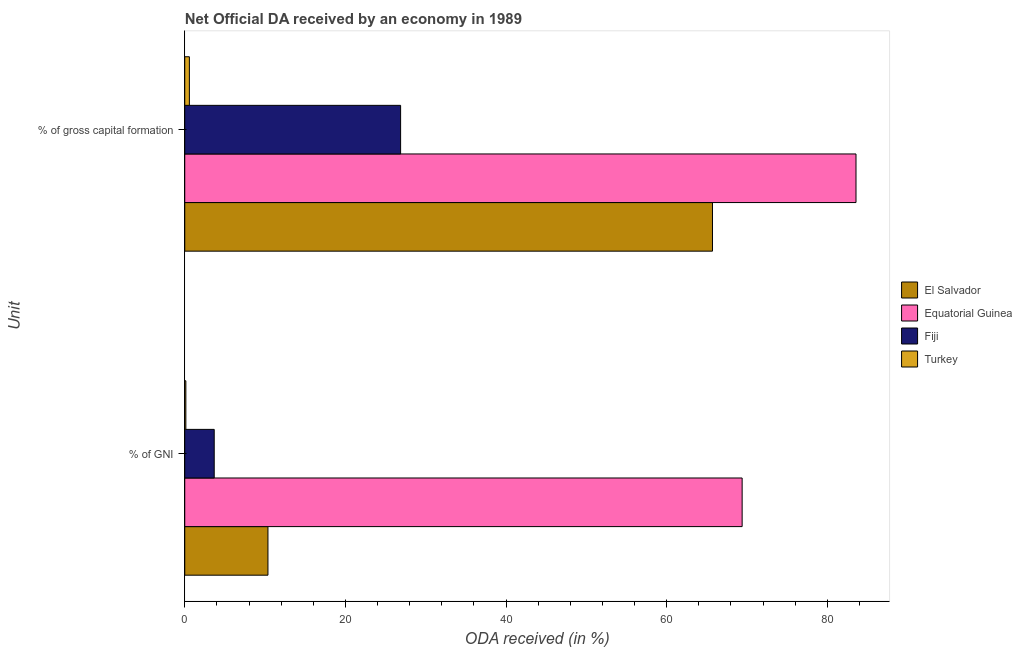Are the number of bars per tick equal to the number of legend labels?
Provide a short and direct response. Yes. What is the label of the 2nd group of bars from the top?
Give a very brief answer. % of GNI. What is the oda received as percentage of gross capital formation in El Salvador?
Keep it short and to the point. 65.71. Across all countries, what is the maximum oda received as percentage of gross capital formation?
Provide a short and direct response. 83.58. Across all countries, what is the minimum oda received as percentage of gross capital formation?
Your answer should be compact. 0.58. In which country was the oda received as percentage of gross capital formation maximum?
Your answer should be very brief. Equatorial Guinea. What is the total oda received as percentage of gni in the graph?
Your response must be concise. 83.57. What is the difference between the oda received as percentage of gross capital formation in Fiji and that in Equatorial Guinea?
Ensure brevity in your answer.  -56.7. What is the difference between the oda received as percentage of gni in Turkey and the oda received as percentage of gross capital formation in Fiji?
Make the answer very short. -26.74. What is the average oda received as percentage of gross capital formation per country?
Your response must be concise. 44.19. What is the difference between the oda received as percentage of gni and oda received as percentage of gross capital formation in Fiji?
Offer a very short reply. -23.21. In how many countries, is the oda received as percentage of gross capital formation greater than 44 %?
Your answer should be compact. 2. What is the ratio of the oda received as percentage of gross capital formation in Fiji to that in Turkey?
Provide a short and direct response. 46.65. Is the oda received as percentage of gross capital formation in Fiji less than that in El Salvador?
Your answer should be compact. Yes. What does the 2nd bar from the top in % of gross capital formation represents?
Ensure brevity in your answer.  Fiji. Are the values on the major ticks of X-axis written in scientific E-notation?
Your answer should be compact. No. Does the graph contain any zero values?
Ensure brevity in your answer.  No. Does the graph contain grids?
Your response must be concise. No. What is the title of the graph?
Ensure brevity in your answer.  Net Official DA received by an economy in 1989. What is the label or title of the X-axis?
Offer a terse response. ODA received (in %). What is the label or title of the Y-axis?
Give a very brief answer. Unit. What is the ODA received (in %) of El Salvador in % of GNI?
Your answer should be very brief. 10.36. What is the ODA received (in %) of Equatorial Guinea in % of GNI?
Make the answer very short. 69.4. What is the ODA received (in %) of Fiji in % of GNI?
Offer a terse response. 3.67. What is the ODA received (in %) of Turkey in % of GNI?
Make the answer very short. 0.14. What is the ODA received (in %) in El Salvador in % of gross capital formation?
Ensure brevity in your answer.  65.71. What is the ODA received (in %) in Equatorial Guinea in % of gross capital formation?
Give a very brief answer. 83.58. What is the ODA received (in %) of Fiji in % of gross capital formation?
Make the answer very short. 26.88. What is the ODA received (in %) of Turkey in % of gross capital formation?
Offer a terse response. 0.58. Across all Unit, what is the maximum ODA received (in %) in El Salvador?
Your response must be concise. 65.71. Across all Unit, what is the maximum ODA received (in %) of Equatorial Guinea?
Keep it short and to the point. 83.58. Across all Unit, what is the maximum ODA received (in %) of Fiji?
Provide a short and direct response. 26.88. Across all Unit, what is the maximum ODA received (in %) in Turkey?
Your answer should be very brief. 0.58. Across all Unit, what is the minimum ODA received (in %) of El Salvador?
Your answer should be very brief. 10.36. Across all Unit, what is the minimum ODA received (in %) of Equatorial Guinea?
Ensure brevity in your answer.  69.4. Across all Unit, what is the minimum ODA received (in %) of Fiji?
Make the answer very short. 3.67. Across all Unit, what is the minimum ODA received (in %) of Turkey?
Your response must be concise. 0.14. What is the total ODA received (in %) of El Salvador in the graph?
Make the answer very short. 76.07. What is the total ODA received (in %) of Equatorial Guinea in the graph?
Your answer should be very brief. 152.98. What is the total ODA received (in %) in Fiji in the graph?
Your answer should be very brief. 30.55. What is the total ODA received (in %) of Turkey in the graph?
Your answer should be compact. 0.71. What is the difference between the ODA received (in %) in El Salvador in % of GNI and that in % of gross capital formation?
Your answer should be compact. -55.35. What is the difference between the ODA received (in %) in Equatorial Guinea in % of GNI and that in % of gross capital formation?
Your answer should be compact. -14.18. What is the difference between the ODA received (in %) in Fiji in % of GNI and that in % of gross capital formation?
Provide a short and direct response. -23.21. What is the difference between the ODA received (in %) of Turkey in % of GNI and that in % of gross capital formation?
Keep it short and to the point. -0.44. What is the difference between the ODA received (in %) of El Salvador in % of GNI and the ODA received (in %) of Equatorial Guinea in % of gross capital formation?
Ensure brevity in your answer.  -73.22. What is the difference between the ODA received (in %) of El Salvador in % of GNI and the ODA received (in %) of Fiji in % of gross capital formation?
Make the answer very short. -16.52. What is the difference between the ODA received (in %) in El Salvador in % of GNI and the ODA received (in %) in Turkey in % of gross capital formation?
Give a very brief answer. 9.78. What is the difference between the ODA received (in %) of Equatorial Guinea in % of GNI and the ODA received (in %) of Fiji in % of gross capital formation?
Make the answer very short. 42.52. What is the difference between the ODA received (in %) of Equatorial Guinea in % of GNI and the ODA received (in %) of Turkey in % of gross capital formation?
Offer a terse response. 68.83. What is the difference between the ODA received (in %) of Fiji in % of GNI and the ODA received (in %) of Turkey in % of gross capital formation?
Your answer should be compact. 3.09. What is the average ODA received (in %) in El Salvador per Unit?
Ensure brevity in your answer.  38.03. What is the average ODA received (in %) of Equatorial Guinea per Unit?
Your answer should be very brief. 76.49. What is the average ODA received (in %) in Fiji per Unit?
Offer a terse response. 15.27. What is the average ODA received (in %) of Turkey per Unit?
Make the answer very short. 0.36. What is the difference between the ODA received (in %) in El Salvador and ODA received (in %) in Equatorial Guinea in % of GNI?
Your response must be concise. -59.04. What is the difference between the ODA received (in %) in El Salvador and ODA received (in %) in Fiji in % of GNI?
Your answer should be compact. 6.69. What is the difference between the ODA received (in %) in El Salvador and ODA received (in %) in Turkey in % of GNI?
Offer a very short reply. 10.22. What is the difference between the ODA received (in %) of Equatorial Guinea and ODA received (in %) of Fiji in % of GNI?
Give a very brief answer. 65.73. What is the difference between the ODA received (in %) in Equatorial Guinea and ODA received (in %) in Turkey in % of GNI?
Make the answer very short. 69.26. What is the difference between the ODA received (in %) of Fiji and ODA received (in %) of Turkey in % of GNI?
Make the answer very short. 3.53. What is the difference between the ODA received (in %) in El Salvador and ODA received (in %) in Equatorial Guinea in % of gross capital formation?
Keep it short and to the point. -17.87. What is the difference between the ODA received (in %) in El Salvador and ODA received (in %) in Fiji in % of gross capital formation?
Provide a short and direct response. 38.83. What is the difference between the ODA received (in %) in El Salvador and ODA received (in %) in Turkey in % of gross capital formation?
Your answer should be very brief. 65.13. What is the difference between the ODA received (in %) of Equatorial Guinea and ODA received (in %) of Fiji in % of gross capital formation?
Your answer should be very brief. 56.7. What is the difference between the ODA received (in %) of Equatorial Guinea and ODA received (in %) of Turkey in % of gross capital formation?
Your response must be concise. 83. What is the difference between the ODA received (in %) of Fiji and ODA received (in %) of Turkey in % of gross capital formation?
Ensure brevity in your answer.  26.3. What is the ratio of the ODA received (in %) in El Salvador in % of GNI to that in % of gross capital formation?
Offer a terse response. 0.16. What is the ratio of the ODA received (in %) of Equatorial Guinea in % of GNI to that in % of gross capital formation?
Your answer should be compact. 0.83. What is the ratio of the ODA received (in %) in Fiji in % of GNI to that in % of gross capital formation?
Provide a short and direct response. 0.14. What is the ratio of the ODA received (in %) of Turkey in % of GNI to that in % of gross capital formation?
Ensure brevity in your answer.  0.24. What is the difference between the highest and the second highest ODA received (in %) of El Salvador?
Offer a very short reply. 55.35. What is the difference between the highest and the second highest ODA received (in %) of Equatorial Guinea?
Make the answer very short. 14.18. What is the difference between the highest and the second highest ODA received (in %) in Fiji?
Give a very brief answer. 23.21. What is the difference between the highest and the second highest ODA received (in %) in Turkey?
Offer a terse response. 0.44. What is the difference between the highest and the lowest ODA received (in %) of El Salvador?
Keep it short and to the point. 55.35. What is the difference between the highest and the lowest ODA received (in %) in Equatorial Guinea?
Provide a short and direct response. 14.18. What is the difference between the highest and the lowest ODA received (in %) of Fiji?
Provide a succinct answer. 23.21. What is the difference between the highest and the lowest ODA received (in %) in Turkey?
Give a very brief answer. 0.44. 